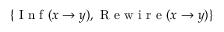Convert formula to latex. <formula><loc_0><loc_0><loc_500><loc_500>\{ { I n f } ( x \to y ) , { R e w i r e } ( x \to y ) \}</formula> 